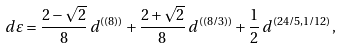Convert formula to latex. <formula><loc_0><loc_0><loc_500><loc_500>d \varepsilon = \frac { 2 - \sqrt { 2 } } { 8 } \, d ^ { ( ( 8 ) ) } + \frac { 2 + \sqrt { 2 } } { 8 } \, d ^ { ( ( 8 / 3 ) ) } + \frac { 1 } { 2 } \, d ^ { ( 2 4 / 5 , 1 / 1 2 ) } ,</formula> 